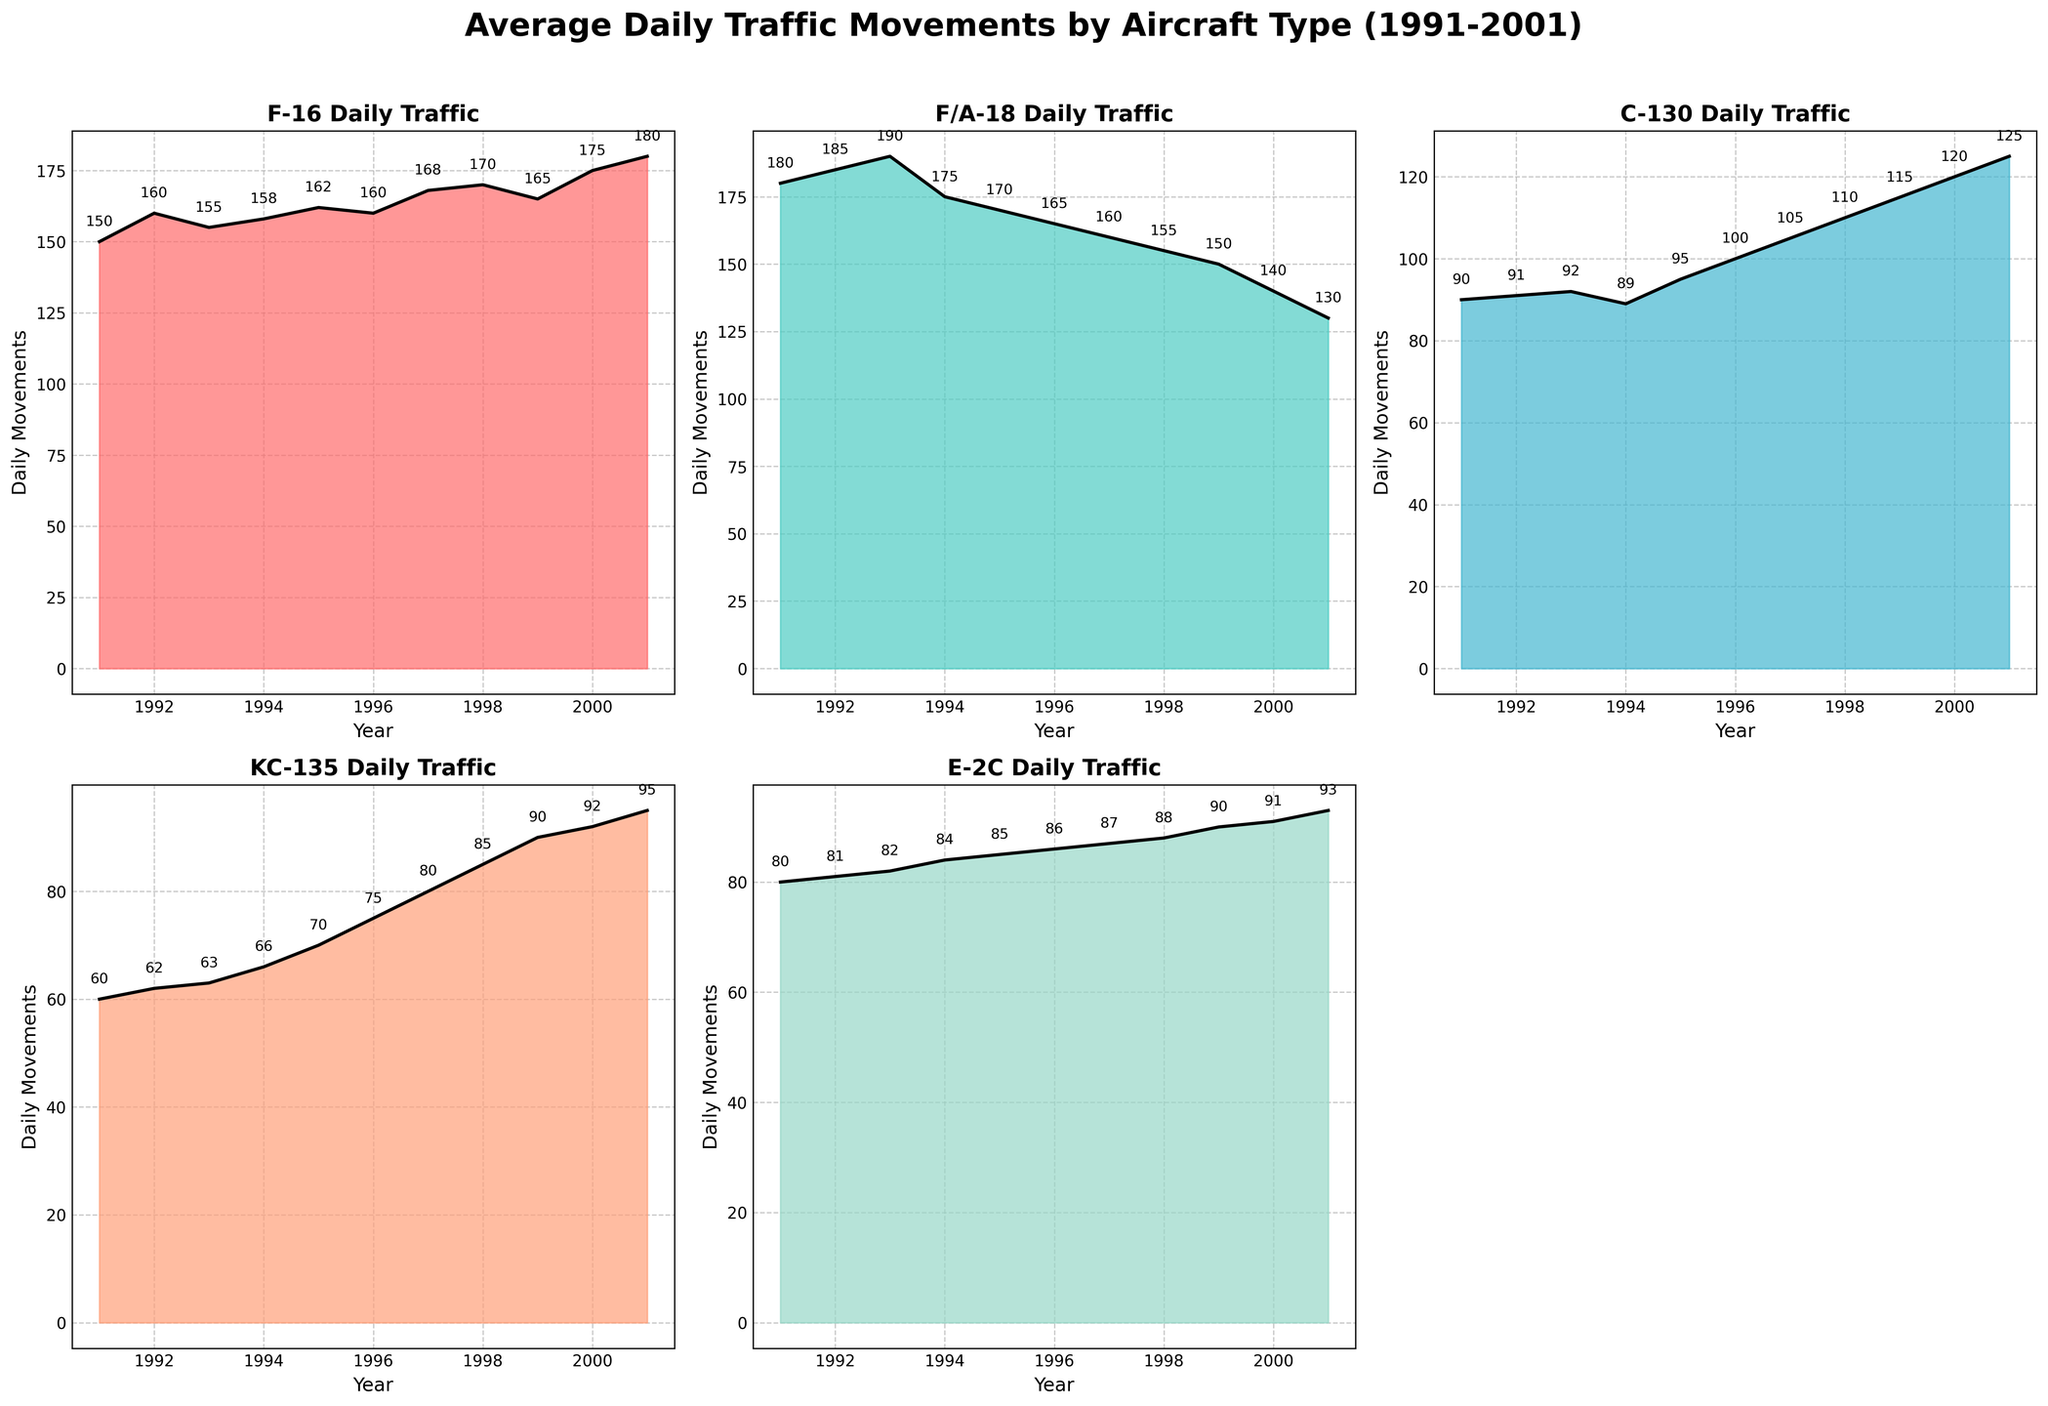What is the title of the figure? The title is positioned at the top of the figure and states the main topic it represents.
Answer: Average Daily Traffic Movements by Aircraft Type (1991-2001) Which aircraft type had the highest daily traffic in 1991? By observing the area charts for the year 1991, the highest point among all aircraft types can be identified.
Answer: F/A-18 What is the difference in daily traffic between the F-16 and C-130 in 1995? From the F-16 and C-130 subplots, subtract the daily traffic value of the C-130 from that of the F-16 for the year 1995.
Answer: 67 Which year shows the highest daily traffic for the KC-135? Inspect the KC-135 subplot and identify the year with the maximum daily traffic value.
Answer: 2001 How many subplots are present in the figure? Count the number of individual area plots featured in the figure.
Answer: 5 What trend can be observed for the F-16 daily traffic from 1991 to 1994? Analyze the F-16 subplot to observe if the daily traffic increases, decreases, or remains stable over these years.
Answer: Slightly fluctuates but generally increases Compare the daily traffic of the F/A-18 and E-2C in 2000. Which one is higher? Check both the F/A-18 and E-2C subplots for the year 2000 and compare their values.
Answer: F/A-18 Calculate the average daily traffic of the E-2C over the displayed years. Sum the daily traffic values in the E-2C subplot and divide by the number of years presented (11).
Answer: 85 What is the general trend observed for the C-130 daily traffic over the years? Check the C-130 subplot for whether the daily traffic shows an increasing, decreasing, or stable pattern.
Answer: Increasing 